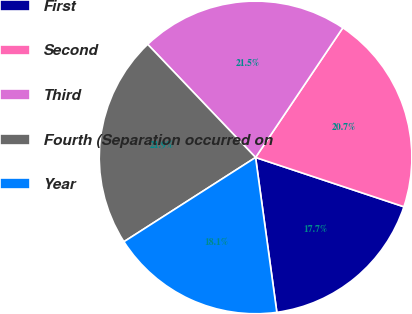Convert chart to OTSL. <chart><loc_0><loc_0><loc_500><loc_500><pie_chart><fcel>First<fcel>Second<fcel>Third<fcel>Fourth (Separation occurred on<fcel>Year<nl><fcel>17.72%<fcel>20.68%<fcel>21.55%<fcel>21.94%<fcel>18.11%<nl></chart> 